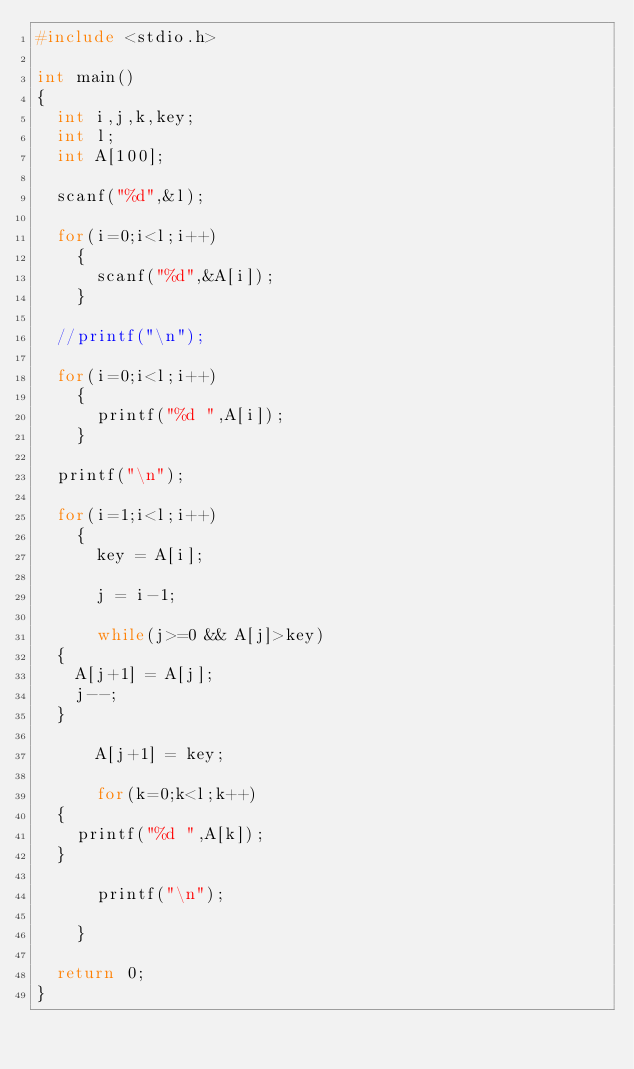Convert code to text. <code><loc_0><loc_0><loc_500><loc_500><_C_>#include <stdio.h>

int main()
{
  int i,j,k,key;
  int l;
  int A[100];
  
  scanf("%d",&l);
  
  for(i=0;i<l;i++)
    {
      scanf("%d",&A[i]);
    }
  
  //printf("\n");
  
  for(i=0;i<l;i++)
    {
      printf("%d ",A[i]);
    }
  
  printf("\n");
  
  for(i=1;i<l;i++)
    {
      key = A[i];

      j = i-1;
      
      while(j>=0 && A[j]>key)
	{
	  A[j+1] = A[j];
	  j--;
	}
  
      A[j+1] = key;
      
      for(k=0;k<l;k++)
	{
	  printf("%d ",A[k]);
	}
      
      printf("\n");
     
    }

  return 0;
}</code> 